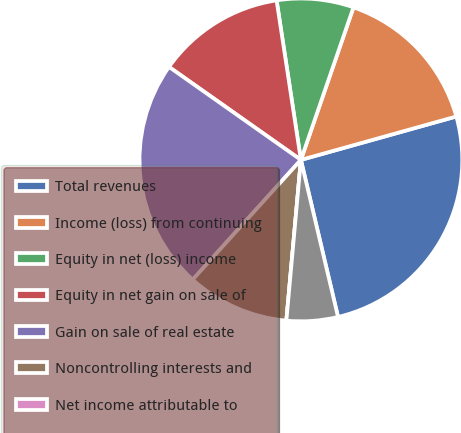<chart> <loc_0><loc_0><loc_500><loc_500><pie_chart><fcel>Total revenues<fcel>Income (loss) from continuing<fcel>Equity in net (loss) income<fcel>Equity in net gain on sale of<fcel>Gain on sale of real estate<fcel>Noncontrolling interests and<fcel>Net income attributable to<fcel>Perpetual preferred units<nl><fcel>25.64%<fcel>15.38%<fcel>7.69%<fcel>12.82%<fcel>23.08%<fcel>10.26%<fcel>0.0%<fcel>5.13%<nl></chart> 